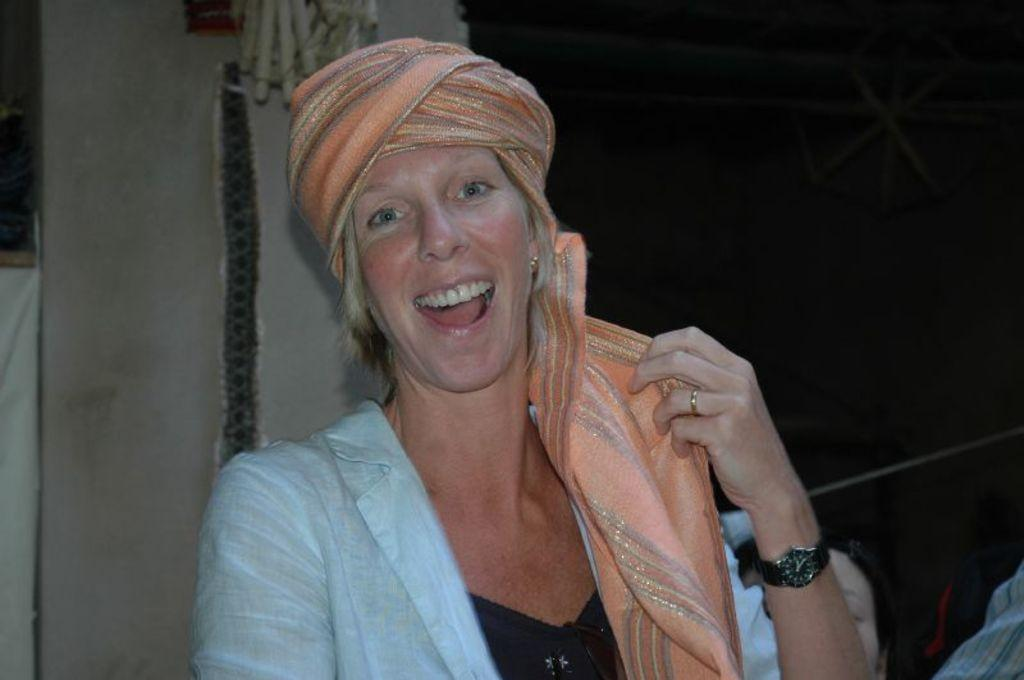Who is the main subject in the image? There is a lady in the image. What can be seen in the background of the image? There is a wall and other objects in the background of the image. What type of trucks can be seen in the image? There are no trucks present in the image. What is the lady talking about in the image? The image does not provide any information about what the lady might be talking about. 